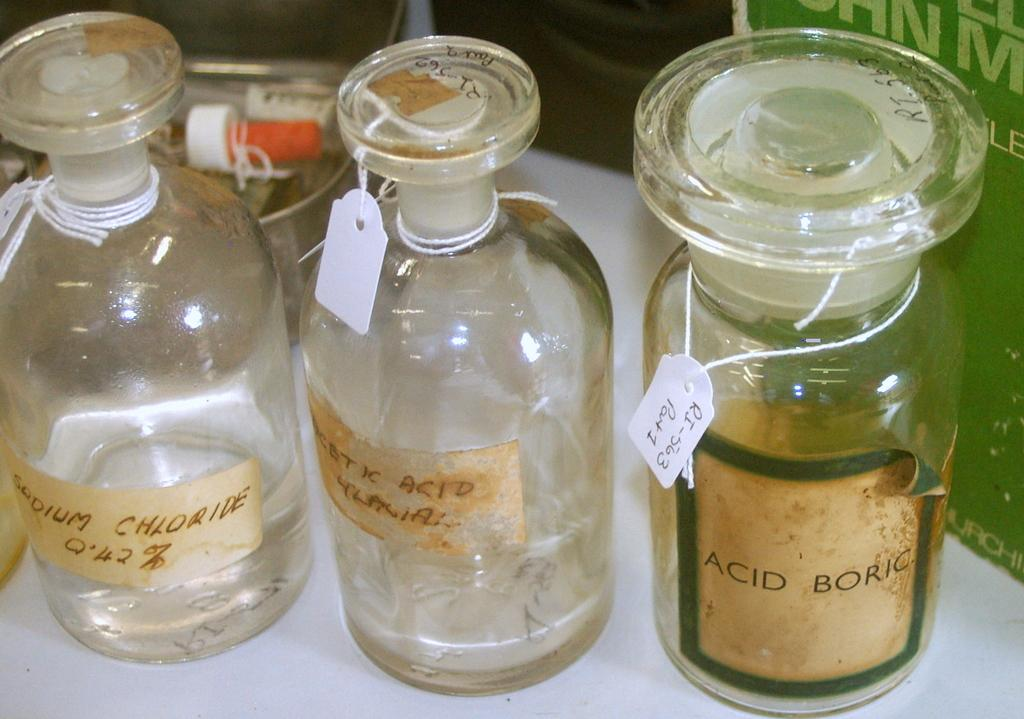<image>
Present a compact description of the photo's key features. Old chemical bottles are lined up on a table, including one labeled ACID BORIC. 